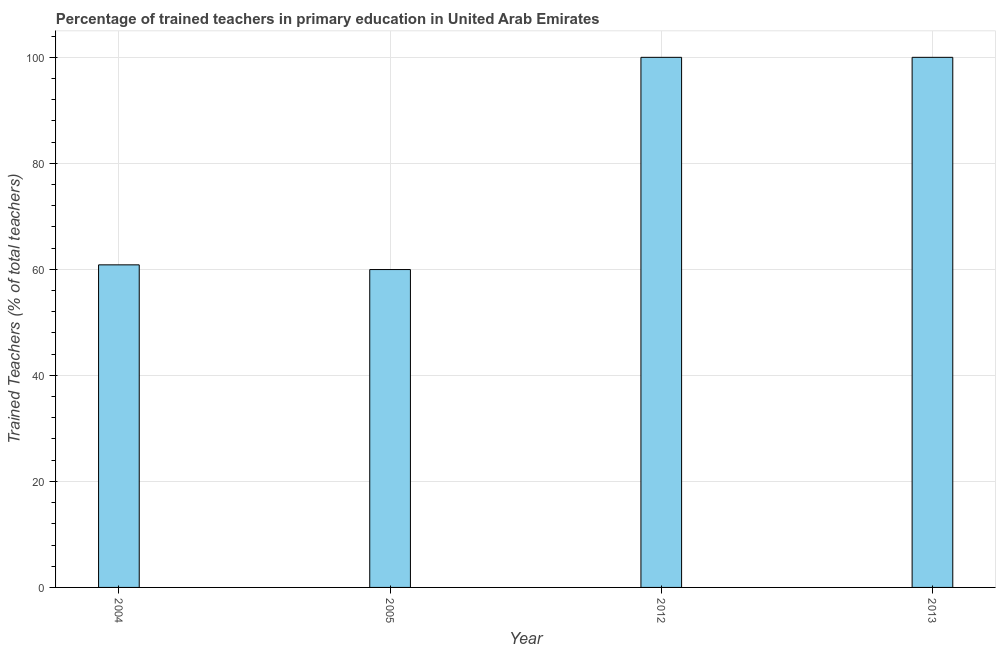Does the graph contain any zero values?
Offer a very short reply. No. What is the title of the graph?
Ensure brevity in your answer.  Percentage of trained teachers in primary education in United Arab Emirates. What is the label or title of the Y-axis?
Your answer should be compact. Trained Teachers (% of total teachers). Across all years, what is the minimum percentage of trained teachers?
Give a very brief answer. 59.97. What is the sum of the percentage of trained teachers?
Your response must be concise. 320.82. What is the difference between the percentage of trained teachers in 2005 and 2012?
Keep it short and to the point. -40.03. What is the average percentage of trained teachers per year?
Offer a terse response. 80.2. What is the median percentage of trained teachers?
Give a very brief answer. 80.43. Do a majority of the years between 2013 and 2004 (inclusive) have percentage of trained teachers greater than 72 %?
Make the answer very short. Yes. Is the percentage of trained teachers in 2004 less than that in 2012?
Offer a terse response. Yes. Is the sum of the percentage of trained teachers in 2004 and 2005 greater than the maximum percentage of trained teachers across all years?
Your answer should be very brief. Yes. What is the difference between the highest and the lowest percentage of trained teachers?
Offer a terse response. 40.03. In how many years, is the percentage of trained teachers greater than the average percentage of trained teachers taken over all years?
Keep it short and to the point. 2. How many bars are there?
Make the answer very short. 4. What is the difference between two consecutive major ticks on the Y-axis?
Give a very brief answer. 20. What is the Trained Teachers (% of total teachers) of 2004?
Ensure brevity in your answer.  60.85. What is the Trained Teachers (% of total teachers) of 2005?
Offer a terse response. 59.97. What is the difference between the Trained Teachers (% of total teachers) in 2004 and 2005?
Offer a terse response. 0.89. What is the difference between the Trained Teachers (% of total teachers) in 2004 and 2012?
Provide a short and direct response. -39.15. What is the difference between the Trained Teachers (% of total teachers) in 2004 and 2013?
Give a very brief answer. -39.15. What is the difference between the Trained Teachers (% of total teachers) in 2005 and 2012?
Your answer should be compact. -40.03. What is the difference between the Trained Teachers (% of total teachers) in 2005 and 2013?
Ensure brevity in your answer.  -40.03. What is the difference between the Trained Teachers (% of total teachers) in 2012 and 2013?
Make the answer very short. 0. What is the ratio of the Trained Teachers (% of total teachers) in 2004 to that in 2012?
Give a very brief answer. 0.61. What is the ratio of the Trained Teachers (% of total teachers) in 2004 to that in 2013?
Offer a terse response. 0.61. What is the ratio of the Trained Teachers (% of total teachers) in 2005 to that in 2012?
Your response must be concise. 0.6. What is the ratio of the Trained Teachers (% of total teachers) in 2005 to that in 2013?
Your answer should be compact. 0.6. 